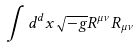<formula> <loc_0><loc_0><loc_500><loc_500>\int d ^ { d } x \sqrt { - g } R ^ { \mu \nu } R _ { \mu \nu }</formula> 